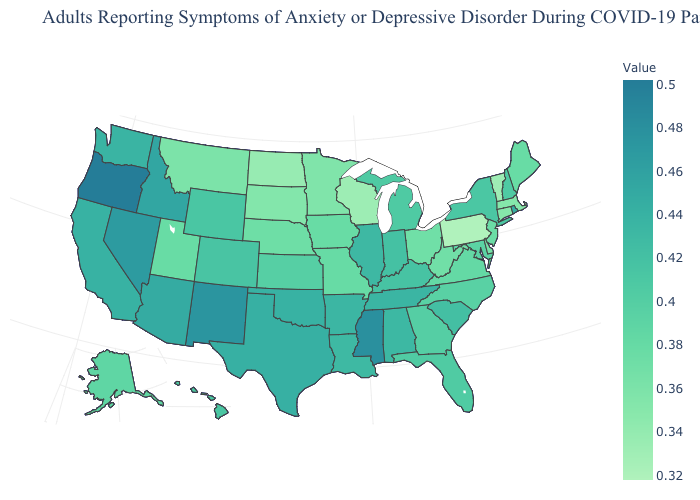Does the map have missing data?
Keep it brief. No. Which states have the lowest value in the USA?
Quick response, please. Pennsylvania. Does North Dakota have a lower value than Oregon?
Short answer required. Yes. Which states have the lowest value in the USA?
Short answer required. Pennsylvania. Among the states that border Massachusetts , which have the highest value?
Be succinct. Rhode Island. Which states have the lowest value in the USA?
Concise answer only. Pennsylvania. 